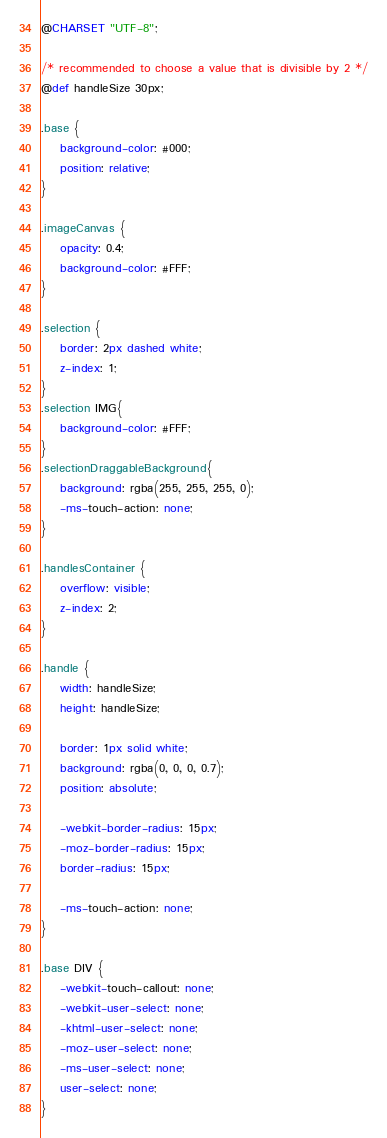Convert code to text. <code><loc_0><loc_0><loc_500><loc_500><_CSS_>@CHARSET "UTF-8";

/* recommended to choose a value that is divisible by 2 */
@def handleSize 30px;

.base {
	background-color: #000;
	position: relative;
}

.imageCanvas {
	opacity: 0.4;
	background-color: #FFF;
}

.selection {
	border: 2px dashed white;
	z-index: 1;
}
.selection IMG{
	background-color: #FFF;
}
.selectionDraggableBackground{
	background: rgba(255, 255, 255, 0);
	-ms-touch-action: none;
}

.handlesContainer {
	overflow: visible;
	z-index: 2;
}

.handle {
	width: handleSize;
	height: handleSize;
	
	border: 1px solid white;
	background: rgba(0, 0, 0, 0.7);
	position: absolute;
	
	-webkit-border-radius: 15px;
	-moz-border-radius: 15px;
	border-radius: 15px;
	
	-ms-touch-action: none;
}

.base DIV {
	-webkit-touch-callout: none;
	-webkit-user-select: none;
	-khtml-user-select: none;
	-moz-user-select: none;
	-ms-user-select: none;
	user-select: none;
}</code> 